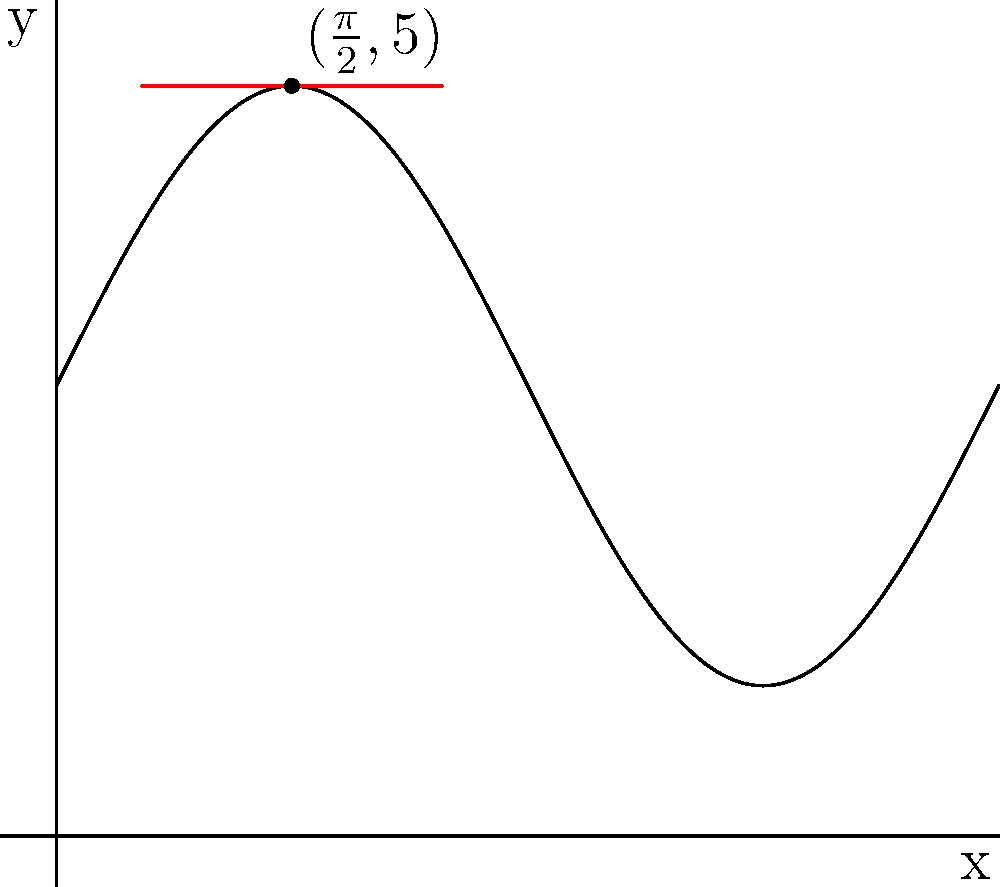The curve $y = 2\sin(x) + 3$ represents the emotional ups and downs of an artist's infertility journey. Find the equation of the tangent line to this curve at the point $(\frac{\pi}{2}, 5)$. To find the equation of the tangent line, we need to follow these steps:

1) The general equation of a tangent line is $y - y_0 = m(x - x_0)$, where $(x_0, y_0)$ is the point of tangency and $m$ is the slope of the tangent line.

2) We're given the point $(\frac{\pi}{2}, 5)$, so $x_0 = \frac{\pi}{2}$ and $y_0 = 5$.

3) To find the slope $m$, we need to differentiate $y = 2\sin(x) + 3$:
   $\frac{dy}{dx} = 2\cos(x)$

4) Evaluate the derivative at $x = \frac{\pi}{2}$:
   $m = 2\cos(\frac{\pi}{2}) = 2(0) = 0$

5) Now we have all the components to write the equation of the tangent line:
   $y - 5 = 0(x - \frac{\pi}{2})$

6) Simplify:
   $y = 5$

This horizontal line represents a moment of stability in the emotional journey, where the rate of change is momentarily zero.
Answer: $y = 5$ 